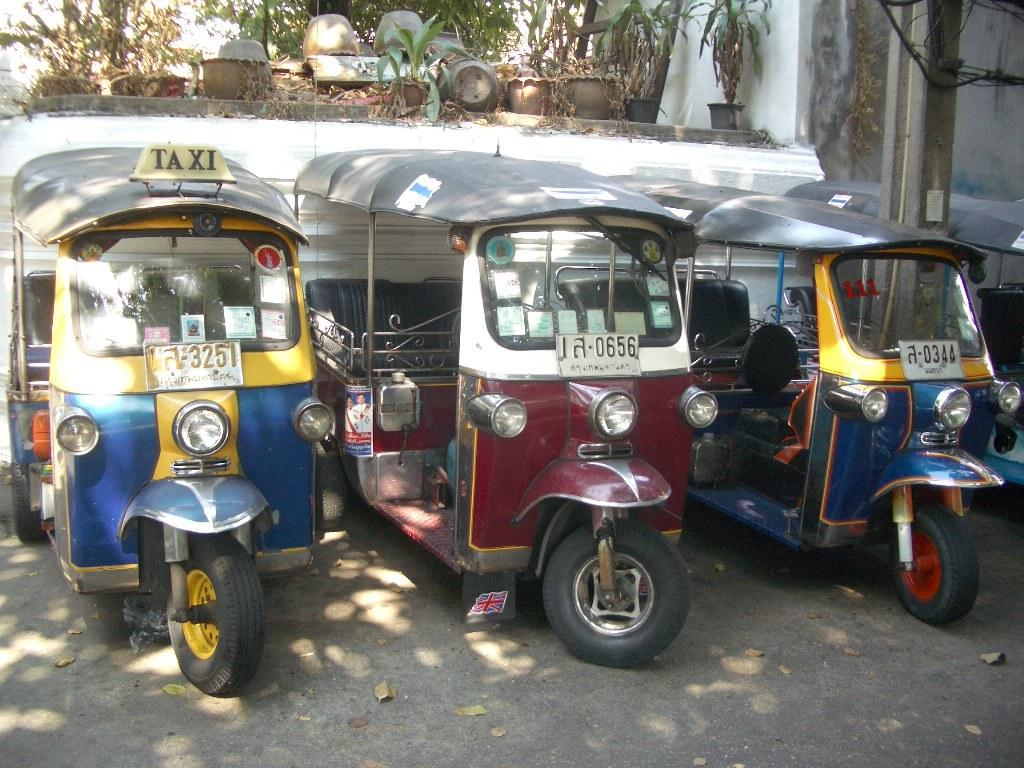What can be seen on the road in the image? There are vehicles on the road in the image. What is located near the road in the image? There is a wall with objects attached to it in the image. What type of plants are present in the image? There are plants in pots in the image. What type of basket can be seen in the image? There is no basket present in the image. 